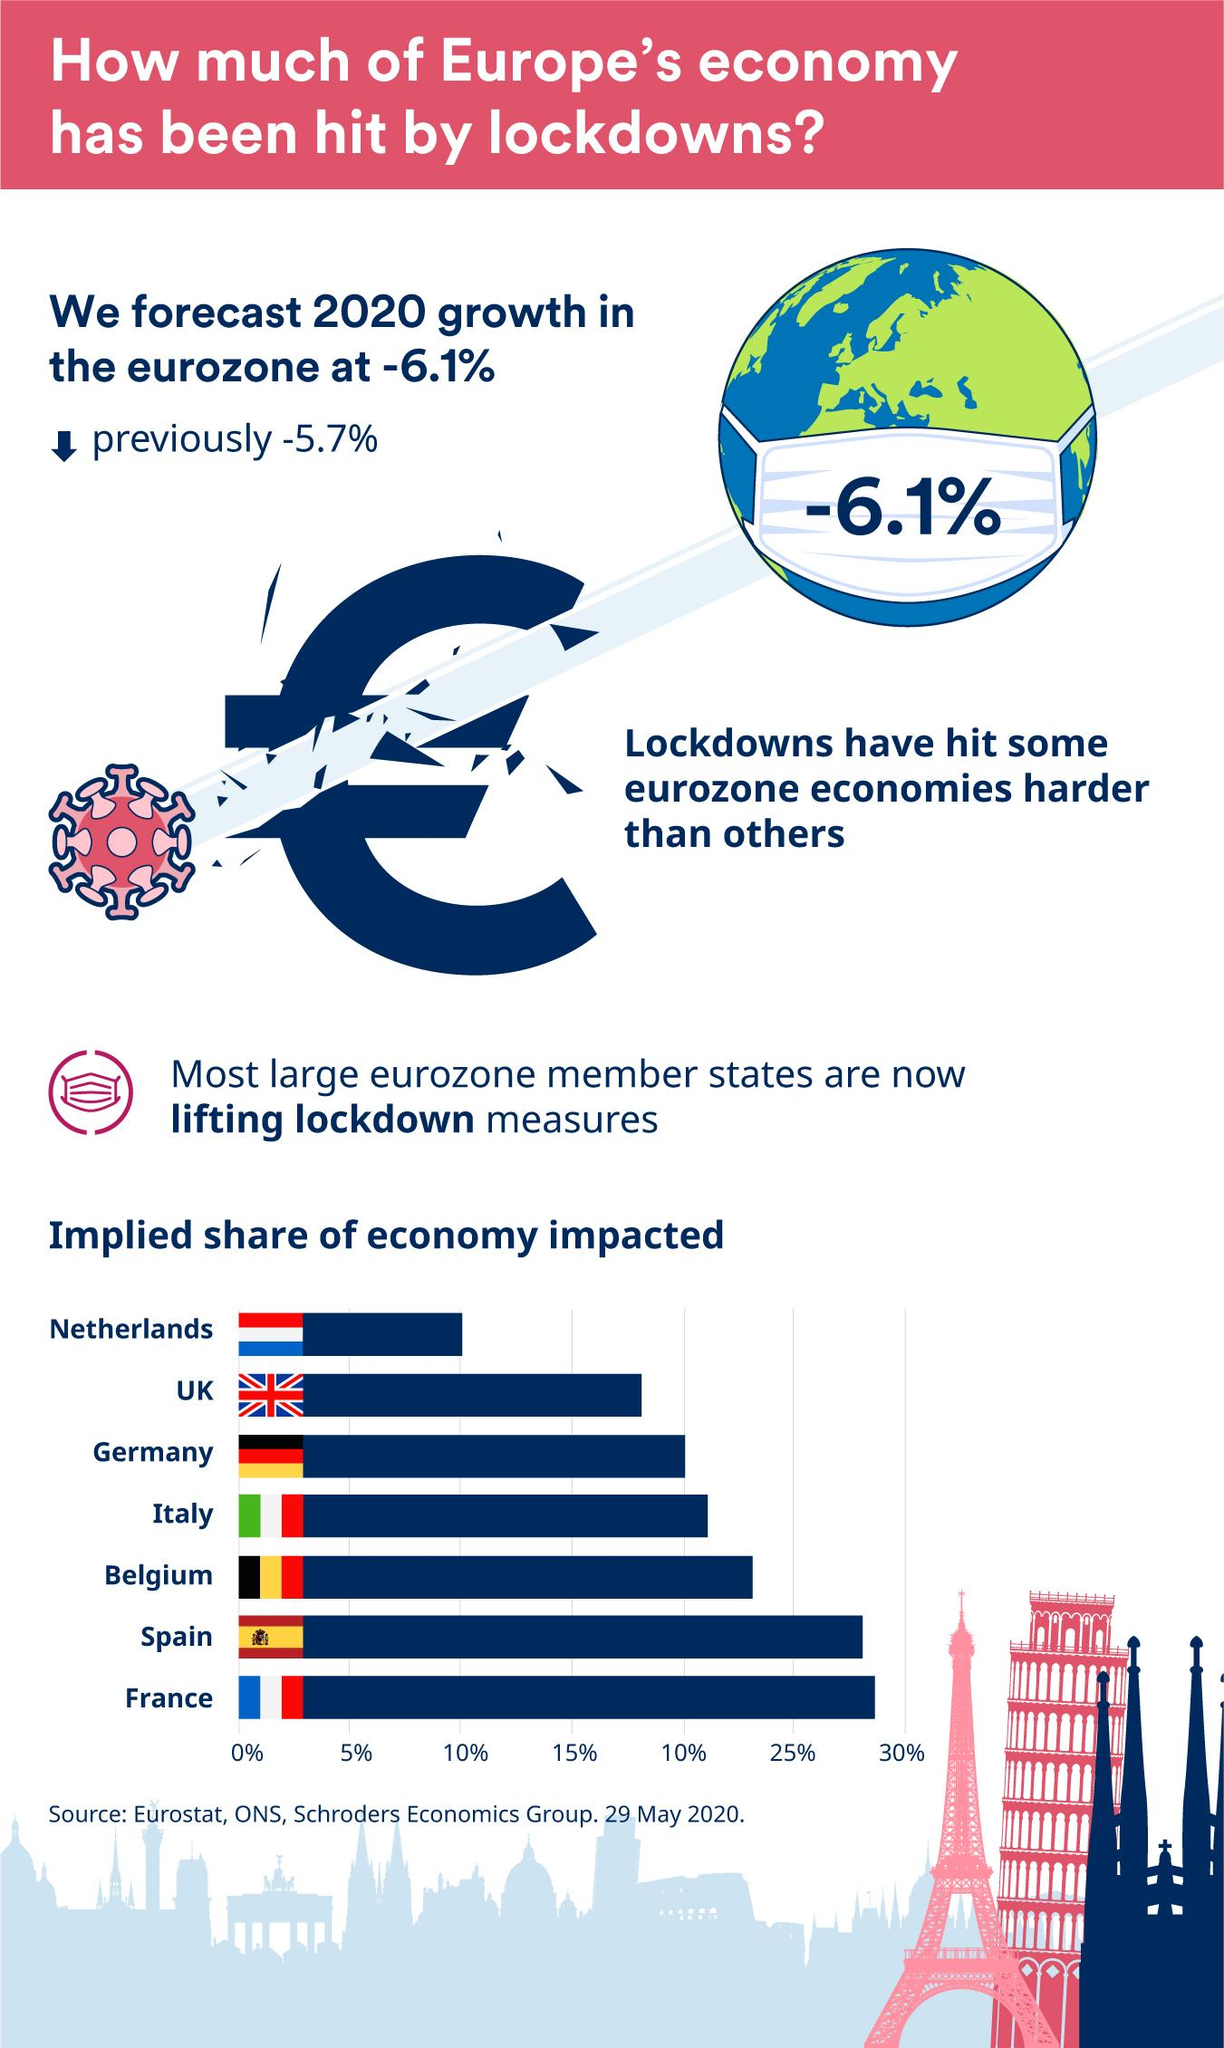Give some essential details in this illustration. The printed result on the mask shows a decrease of -6.1%. The color combination of red, white, and blue is commonly found in the flags of several countries, including the Netherlands, the United Kingdom, and France. The economies of Spain and France have been significantly impacted, with both countries experiencing a decline of over 25%. The Eiffel tower is commonly perceived as being pink in color, but according to recent studies, it is actually blue in hue. The United Kingdom has the second-lowest impact economy among all countries. 